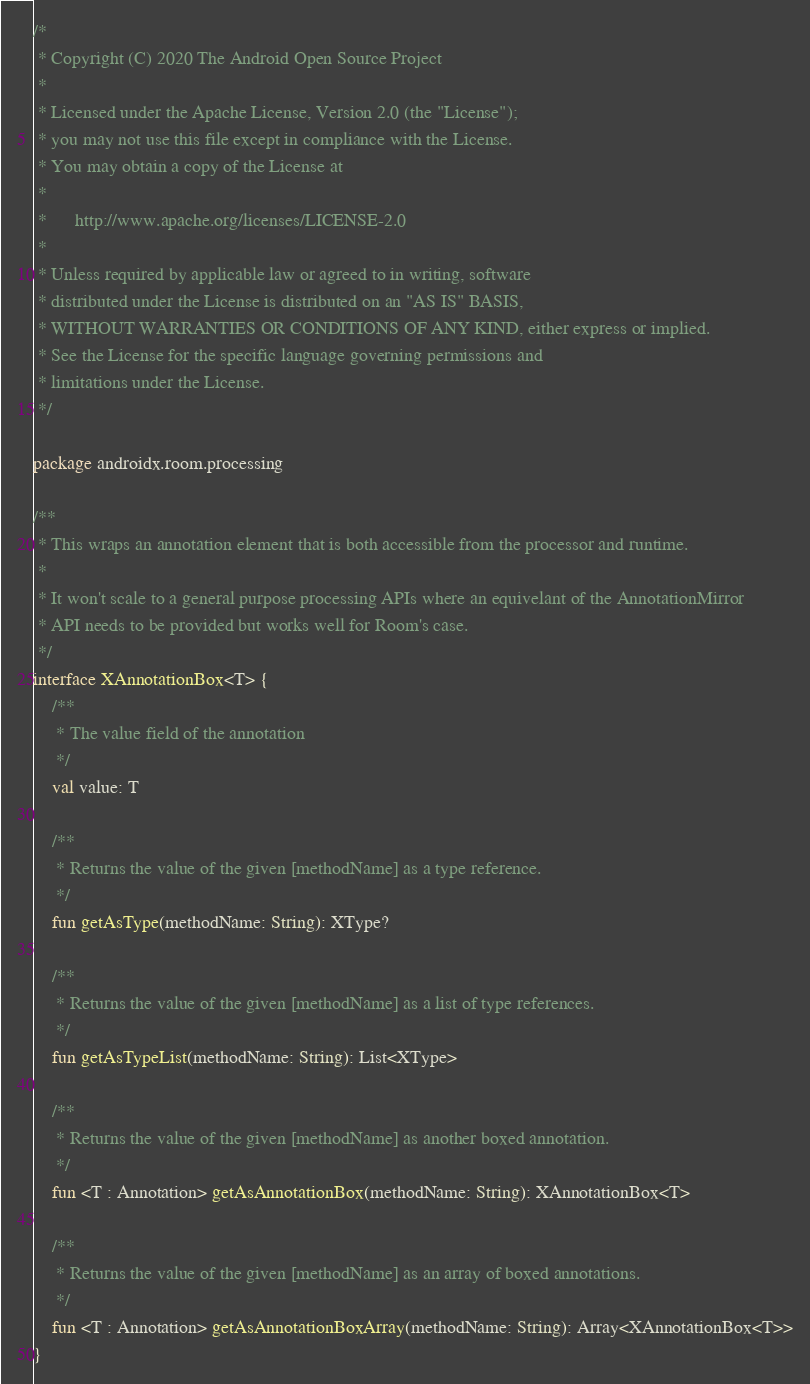Convert code to text. <code><loc_0><loc_0><loc_500><loc_500><_Kotlin_>/*
 * Copyright (C) 2020 The Android Open Source Project
 *
 * Licensed under the Apache License, Version 2.0 (the "License");
 * you may not use this file except in compliance with the License.
 * You may obtain a copy of the License at
 *
 *      http://www.apache.org/licenses/LICENSE-2.0
 *
 * Unless required by applicable law or agreed to in writing, software
 * distributed under the License is distributed on an "AS IS" BASIS,
 * WITHOUT WARRANTIES OR CONDITIONS OF ANY KIND, either express or implied.
 * See the License for the specific language governing permissions and
 * limitations under the License.
 */

package androidx.room.processing

/**
 * This wraps an annotation element that is both accessible from the processor and runtime.
 *
 * It won't scale to a general purpose processing APIs where an equivelant of the AnnotationMirror
 * API needs to be provided but works well for Room's case.
 */
interface XAnnotationBox<T> {
    /**
     * The value field of the annotation
     */
    val value: T

    /**
     * Returns the value of the given [methodName] as a type reference.
     */
    fun getAsType(methodName: String): XType?

    /**
     * Returns the value of the given [methodName] as a list of type references.
     */
    fun getAsTypeList(methodName: String): List<XType>

    /**
     * Returns the value of the given [methodName] as another boxed annotation.
     */
    fun <T : Annotation> getAsAnnotationBox(methodName: String): XAnnotationBox<T>

    /**
     * Returns the value of the given [methodName] as an array of boxed annotations.
     */
    fun <T : Annotation> getAsAnnotationBoxArray(methodName: String): Array<XAnnotationBox<T>>
}</code> 